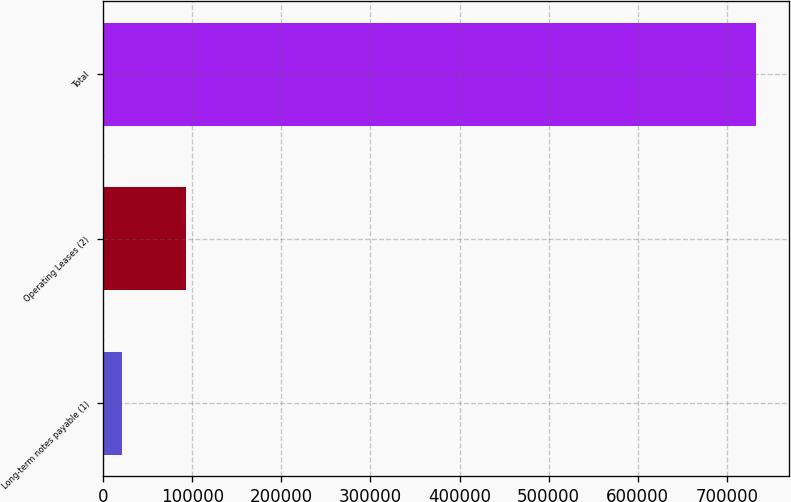Convert chart to OTSL. <chart><loc_0><loc_0><loc_500><loc_500><bar_chart><fcel>Long-term notes payable (1)<fcel>Operating Leases (2)<fcel>Total<nl><fcel>21388<fcel>92529.8<fcel>732806<nl></chart> 